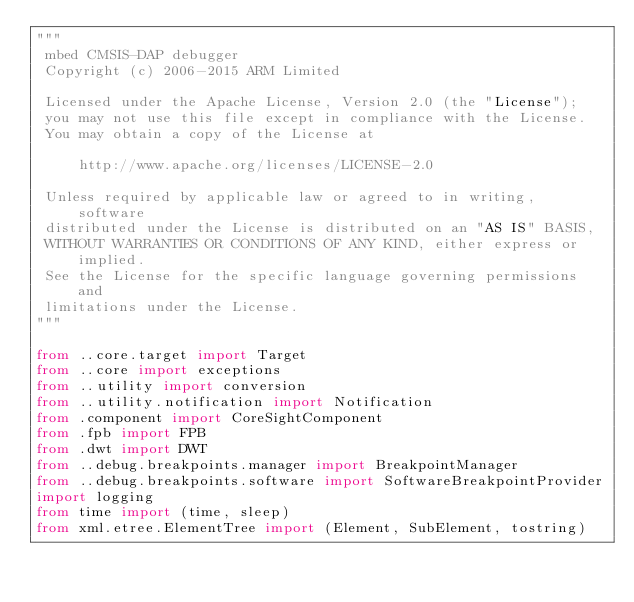Convert code to text. <code><loc_0><loc_0><loc_500><loc_500><_Python_>"""
 mbed CMSIS-DAP debugger
 Copyright (c) 2006-2015 ARM Limited

 Licensed under the Apache License, Version 2.0 (the "License");
 you may not use this file except in compliance with the License.
 You may obtain a copy of the License at

     http://www.apache.org/licenses/LICENSE-2.0

 Unless required by applicable law or agreed to in writing, software
 distributed under the License is distributed on an "AS IS" BASIS,
 WITHOUT WARRANTIES OR CONDITIONS OF ANY KIND, either express or implied.
 See the License for the specific language governing permissions and
 limitations under the License.
"""

from ..core.target import Target
from ..core import exceptions
from ..utility import conversion
from ..utility.notification import Notification
from .component import CoreSightComponent
from .fpb import FPB
from .dwt import DWT
from ..debug.breakpoints.manager import BreakpointManager
from ..debug.breakpoints.software import SoftwareBreakpointProvider
import logging
from time import (time, sleep)
from xml.etree.ElementTree import (Element, SubElement, tostring)
</code> 